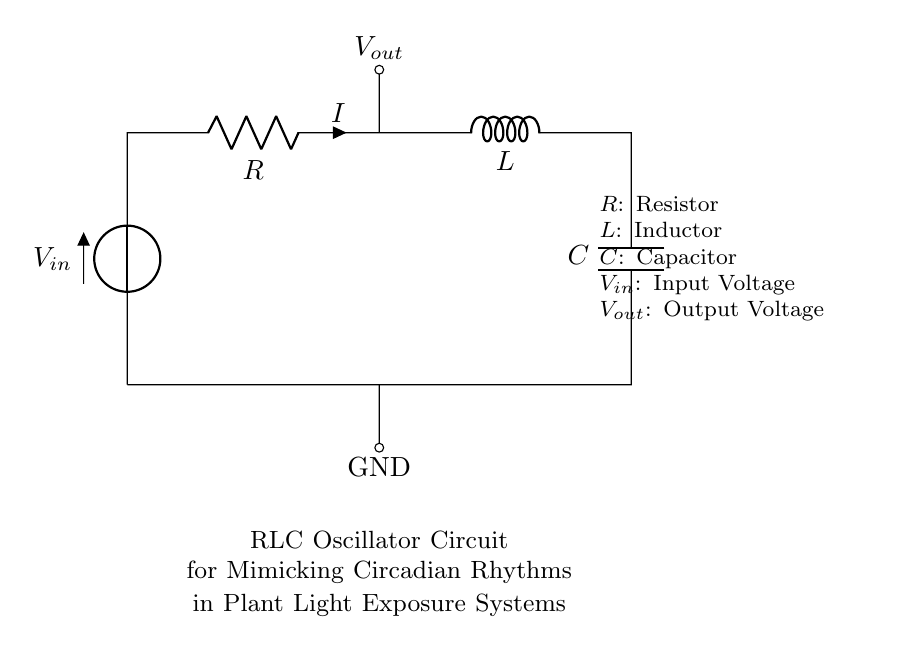What is the input voltage in this circuit? The input voltage is the value denoted by \( V_{in} \) in the circuit diagram. It represents the voltage provided to the circuit.
Answer: \( V_{in} \) What components are present in the circuit? The components can be identified in the circuit diagram: a resistor, an inductor, and a capacitor are all clearly labeled.
Answer: Resistor, Inductor, Capacitor What is the output voltage labeled in the circuit? The output voltage is represented by \( V_{out} \) in the circuit diagram. It indicates the voltage at the point after the resistor.
Answer: \( V_{out} \) What happens to the current as it passes through the inductor? The inductor creates a temporary magnetic field that opposes changes in current. This effect is known as inductance, which is a fundamental property of the inductor.
Answer: Inductance How does the RLC circuit mimic circadian rhythms? The RLC circuit can create oscillations due to the energy exchange between the resistor, inductor, and capacitor, thus simulating periodic patterns similar to circadian rhythms in light exposure systems.
Answer: Energy oscillation What is the role of the resistor in this circuit? The resistor limits the electric current flowing in the circuit, which helps to control the power dissipation and affects the damping of oscillations.
Answer: Limits current 